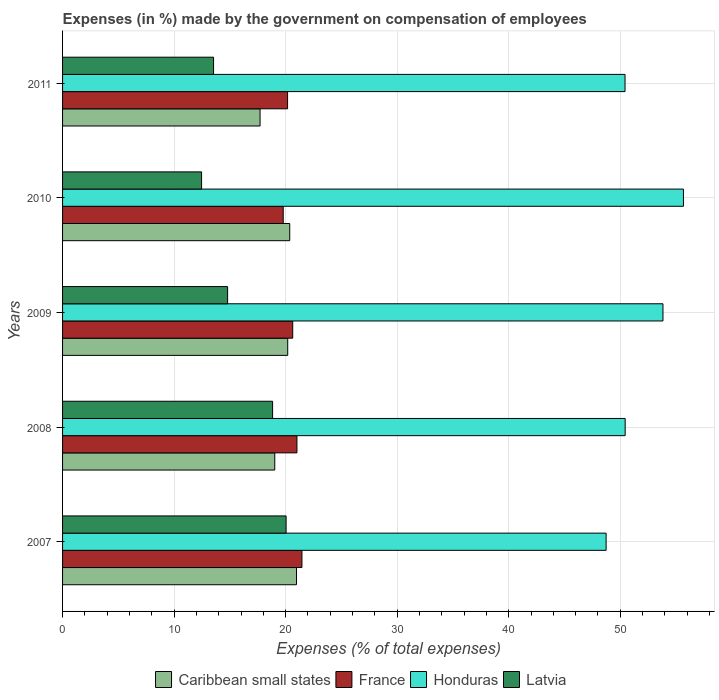Are the number of bars per tick equal to the number of legend labels?
Offer a very short reply. Yes. How many bars are there on the 4th tick from the top?
Provide a succinct answer. 4. What is the label of the 1st group of bars from the top?
Ensure brevity in your answer.  2011. What is the percentage of expenses made by the government on compensation of employees in Caribbean small states in 2010?
Your answer should be very brief. 20.37. Across all years, what is the maximum percentage of expenses made by the government on compensation of employees in France?
Your response must be concise. 21.46. Across all years, what is the minimum percentage of expenses made by the government on compensation of employees in Latvia?
Your answer should be compact. 12.46. What is the total percentage of expenses made by the government on compensation of employees in Latvia in the graph?
Your answer should be compact. 79.67. What is the difference between the percentage of expenses made by the government on compensation of employees in Honduras in 2007 and that in 2008?
Offer a very short reply. -1.71. What is the difference between the percentage of expenses made by the government on compensation of employees in France in 2010 and the percentage of expenses made by the government on compensation of employees in Honduras in 2011?
Provide a short and direct response. -30.65. What is the average percentage of expenses made by the government on compensation of employees in Caribbean small states per year?
Your answer should be very brief. 19.65. In the year 2010, what is the difference between the percentage of expenses made by the government on compensation of employees in Caribbean small states and percentage of expenses made by the government on compensation of employees in Latvia?
Your answer should be very brief. 7.91. What is the ratio of the percentage of expenses made by the government on compensation of employees in Latvia in 2007 to that in 2009?
Your answer should be very brief. 1.35. Is the difference between the percentage of expenses made by the government on compensation of employees in Caribbean small states in 2007 and 2011 greater than the difference between the percentage of expenses made by the government on compensation of employees in Latvia in 2007 and 2011?
Make the answer very short. No. What is the difference between the highest and the second highest percentage of expenses made by the government on compensation of employees in Caribbean small states?
Your answer should be compact. 0.61. What is the difference between the highest and the lowest percentage of expenses made by the government on compensation of employees in Latvia?
Give a very brief answer. 7.58. In how many years, is the percentage of expenses made by the government on compensation of employees in Caribbean small states greater than the average percentage of expenses made by the government on compensation of employees in Caribbean small states taken over all years?
Provide a succinct answer. 3. What does the 3rd bar from the top in 2011 represents?
Provide a succinct answer. France. What does the 3rd bar from the bottom in 2009 represents?
Your answer should be compact. Honduras. Is it the case that in every year, the sum of the percentage of expenses made by the government on compensation of employees in Latvia and percentage of expenses made by the government on compensation of employees in France is greater than the percentage of expenses made by the government on compensation of employees in Honduras?
Give a very brief answer. No. How many bars are there?
Offer a very short reply. 20. What is the difference between two consecutive major ticks on the X-axis?
Your response must be concise. 10. Does the graph contain any zero values?
Your answer should be compact. No. Does the graph contain grids?
Give a very brief answer. Yes. Where does the legend appear in the graph?
Make the answer very short. Bottom center. How many legend labels are there?
Your answer should be compact. 4. How are the legend labels stacked?
Your answer should be very brief. Horizontal. What is the title of the graph?
Keep it short and to the point. Expenses (in %) made by the government on compensation of employees. Does "Sweden" appear as one of the legend labels in the graph?
Keep it short and to the point. No. What is the label or title of the X-axis?
Your response must be concise. Expenses (% of total expenses). What is the label or title of the Y-axis?
Your answer should be compact. Years. What is the Expenses (% of total expenses) of Caribbean small states in 2007?
Your answer should be very brief. 20.98. What is the Expenses (% of total expenses) of France in 2007?
Keep it short and to the point. 21.46. What is the Expenses (% of total expenses) in Honduras in 2007?
Offer a very short reply. 48.73. What is the Expenses (% of total expenses) of Latvia in 2007?
Your answer should be compact. 20.04. What is the Expenses (% of total expenses) of Caribbean small states in 2008?
Your answer should be very brief. 19.03. What is the Expenses (% of total expenses) of France in 2008?
Provide a succinct answer. 21.01. What is the Expenses (% of total expenses) in Honduras in 2008?
Provide a short and direct response. 50.44. What is the Expenses (% of total expenses) of Latvia in 2008?
Ensure brevity in your answer.  18.83. What is the Expenses (% of total expenses) of Caribbean small states in 2009?
Provide a short and direct response. 20.19. What is the Expenses (% of total expenses) in France in 2009?
Your response must be concise. 20.63. What is the Expenses (% of total expenses) of Honduras in 2009?
Your answer should be very brief. 53.83. What is the Expenses (% of total expenses) of Latvia in 2009?
Keep it short and to the point. 14.8. What is the Expenses (% of total expenses) of Caribbean small states in 2010?
Your answer should be very brief. 20.37. What is the Expenses (% of total expenses) in France in 2010?
Give a very brief answer. 19.78. What is the Expenses (% of total expenses) of Honduras in 2010?
Offer a terse response. 55.67. What is the Expenses (% of total expenses) in Latvia in 2010?
Your response must be concise. 12.46. What is the Expenses (% of total expenses) in Caribbean small states in 2011?
Give a very brief answer. 17.71. What is the Expenses (% of total expenses) in France in 2011?
Offer a terse response. 20.17. What is the Expenses (% of total expenses) of Honduras in 2011?
Your answer should be compact. 50.43. What is the Expenses (% of total expenses) of Latvia in 2011?
Make the answer very short. 13.54. Across all years, what is the maximum Expenses (% of total expenses) of Caribbean small states?
Offer a very short reply. 20.98. Across all years, what is the maximum Expenses (% of total expenses) in France?
Ensure brevity in your answer.  21.46. Across all years, what is the maximum Expenses (% of total expenses) of Honduras?
Give a very brief answer. 55.67. Across all years, what is the maximum Expenses (% of total expenses) of Latvia?
Your answer should be compact. 20.04. Across all years, what is the minimum Expenses (% of total expenses) in Caribbean small states?
Provide a short and direct response. 17.71. Across all years, what is the minimum Expenses (% of total expenses) in France?
Make the answer very short. 19.78. Across all years, what is the minimum Expenses (% of total expenses) of Honduras?
Provide a succinct answer. 48.73. Across all years, what is the minimum Expenses (% of total expenses) in Latvia?
Give a very brief answer. 12.46. What is the total Expenses (% of total expenses) in Caribbean small states in the graph?
Your answer should be compact. 98.26. What is the total Expenses (% of total expenses) in France in the graph?
Ensure brevity in your answer.  103.07. What is the total Expenses (% of total expenses) of Honduras in the graph?
Make the answer very short. 259.1. What is the total Expenses (% of total expenses) of Latvia in the graph?
Make the answer very short. 79.67. What is the difference between the Expenses (% of total expenses) in Caribbean small states in 2007 and that in 2008?
Ensure brevity in your answer.  1.95. What is the difference between the Expenses (% of total expenses) of France in 2007 and that in 2008?
Provide a succinct answer. 0.45. What is the difference between the Expenses (% of total expenses) of Honduras in 2007 and that in 2008?
Your answer should be compact. -1.71. What is the difference between the Expenses (% of total expenses) in Latvia in 2007 and that in 2008?
Keep it short and to the point. 1.21. What is the difference between the Expenses (% of total expenses) of Caribbean small states in 2007 and that in 2009?
Provide a short and direct response. 0.79. What is the difference between the Expenses (% of total expenses) of France in 2007 and that in 2009?
Your answer should be very brief. 0.83. What is the difference between the Expenses (% of total expenses) in Honduras in 2007 and that in 2009?
Make the answer very short. -5.1. What is the difference between the Expenses (% of total expenses) in Latvia in 2007 and that in 2009?
Provide a short and direct response. 5.24. What is the difference between the Expenses (% of total expenses) of Caribbean small states in 2007 and that in 2010?
Give a very brief answer. 0.61. What is the difference between the Expenses (% of total expenses) in France in 2007 and that in 2010?
Your answer should be compact. 1.68. What is the difference between the Expenses (% of total expenses) in Honduras in 2007 and that in 2010?
Give a very brief answer. -6.93. What is the difference between the Expenses (% of total expenses) of Latvia in 2007 and that in 2010?
Provide a short and direct response. 7.58. What is the difference between the Expenses (% of total expenses) of Caribbean small states in 2007 and that in 2011?
Give a very brief answer. 3.27. What is the difference between the Expenses (% of total expenses) of France in 2007 and that in 2011?
Provide a short and direct response. 1.29. What is the difference between the Expenses (% of total expenses) in Honduras in 2007 and that in 2011?
Provide a short and direct response. -1.7. What is the difference between the Expenses (% of total expenses) in Latvia in 2007 and that in 2011?
Offer a terse response. 6.5. What is the difference between the Expenses (% of total expenses) in Caribbean small states in 2008 and that in 2009?
Ensure brevity in your answer.  -1.16. What is the difference between the Expenses (% of total expenses) in France in 2008 and that in 2009?
Give a very brief answer. 0.38. What is the difference between the Expenses (% of total expenses) of Honduras in 2008 and that in 2009?
Offer a very short reply. -3.39. What is the difference between the Expenses (% of total expenses) of Latvia in 2008 and that in 2009?
Make the answer very short. 4.03. What is the difference between the Expenses (% of total expenses) in Caribbean small states in 2008 and that in 2010?
Provide a short and direct response. -1.34. What is the difference between the Expenses (% of total expenses) in France in 2008 and that in 2010?
Offer a very short reply. 1.23. What is the difference between the Expenses (% of total expenses) in Honduras in 2008 and that in 2010?
Ensure brevity in your answer.  -5.23. What is the difference between the Expenses (% of total expenses) of Latvia in 2008 and that in 2010?
Offer a terse response. 6.37. What is the difference between the Expenses (% of total expenses) of Caribbean small states in 2008 and that in 2011?
Keep it short and to the point. 1.32. What is the difference between the Expenses (% of total expenses) in France in 2008 and that in 2011?
Your answer should be very brief. 0.84. What is the difference between the Expenses (% of total expenses) of Honduras in 2008 and that in 2011?
Offer a very short reply. 0.01. What is the difference between the Expenses (% of total expenses) in Latvia in 2008 and that in 2011?
Offer a terse response. 5.29. What is the difference between the Expenses (% of total expenses) of Caribbean small states in 2009 and that in 2010?
Provide a short and direct response. -0.18. What is the difference between the Expenses (% of total expenses) in France in 2009 and that in 2010?
Your response must be concise. 0.85. What is the difference between the Expenses (% of total expenses) of Honduras in 2009 and that in 2010?
Provide a short and direct response. -1.84. What is the difference between the Expenses (% of total expenses) in Latvia in 2009 and that in 2010?
Give a very brief answer. 2.33. What is the difference between the Expenses (% of total expenses) in Caribbean small states in 2009 and that in 2011?
Provide a succinct answer. 2.48. What is the difference between the Expenses (% of total expenses) of France in 2009 and that in 2011?
Ensure brevity in your answer.  0.46. What is the difference between the Expenses (% of total expenses) of Honduras in 2009 and that in 2011?
Offer a terse response. 3.4. What is the difference between the Expenses (% of total expenses) of Latvia in 2009 and that in 2011?
Make the answer very short. 1.26. What is the difference between the Expenses (% of total expenses) in Caribbean small states in 2010 and that in 2011?
Your answer should be very brief. 2.66. What is the difference between the Expenses (% of total expenses) of France in 2010 and that in 2011?
Your response must be concise. -0.39. What is the difference between the Expenses (% of total expenses) of Honduras in 2010 and that in 2011?
Give a very brief answer. 5.24. What is the difference between the Expenses (% of total expenses) of Latvia in 2010 and that in 2011?
Make the answer very short. -1.07. What is the difference between the Expenses (% of total expenses) in Caribbean small states in 2007 and the Expenses (% of total expenses) in France in 2008?
Provide a short and direct response. -0.04. What is the difference between the Expenses (% of total expenses) in Caribbean small states in 2007 and the Expenses (% of total expenses) in Honduras in 2008?
Provide a succinct answer. -29.47. What is the difference between the Expenses (% of total expenses) in Caribbean small states in 2007 and the Expenses (% of total expenses) in Latvia in 2008?
Ensure brevity in your answer.  2.15. What is the difference between the Expenses (% of total expenses) of France in 2007 and the Expenses (% of total expenses) of Honduras in 2008?
Give a very brief answer. -28.98. What is the difference between the Expenses (% of total expenses) of France in 2007 and the Expenses (% of total expenses) of Latvia in 2008?
Offer a terse response. 2.63. What is the difference between the Expenses (% of total expenses) in Honduras in 2007 and the Expenses (% of total expenses) in Latvia in 2008?
Give a very brief answer. 29.9. What is the difference between the Expenses (% of total expenses) in Caribbean small states in 2007 and the Expenses (% of total expenses) in France in 2009?
Ensure brevity in your answer.  0.34. What is the difference between the Expenses (% of total expenses) in Caribbean small states in 2007 and the Expenses (% of total expenses) in Honduras in 2009?
Your answer should be compact. -32.86. What is the difference between the Expenses (% of total expenses) in Caribbean small states in 2007 and the Expenses (% of total expenses) in Latvia in 2009?
Your answer should be compact. 6.18. What is the difference between the Expenses (% of total expenses) in France in 2007 and the Expenses (% of total expenses) in Honduras in 2009?
Your answer should be very brief. -32.37. What is the difference between the Expenses (% of total expenses) of France in 2007 and the Expenses (% of total expenses) of Latvia in 2009?
Provide a short and direct response. 6.66. What is the difference between the Expenses (% of total expenses) in Honduras in 2007 and the Expenses (% of total expenses) in Latvia in 2009?
Offer a terse response. 33.94. What is the difference between the Expenses (% of total expenses) of Caribbean small states in 2007 and the Expenses (% of total expenses) of France in 2010?
Keep it short and to the point. 1.19. What is the difference between the Expenses (% of total expenses) of Caribbean small states in 2007 and the Expenses (% of total expenses) of Honduras in 2010?
Ensure brevity in your answer.  -34.69. What is the difference between the Expenses (% of total expenses) of Caribbean small states in 2007 and the Expenses (% of total expenses) of Latvia in 2010?
Offer a very short reply. 8.51. What is the difference between the Expenses (% of total expenses) of France in 2007 and the Expenses (% of total expenses) of Honduras in 2010?
Make the answer very short. -34.21. What is the difference between the Expenses (% of total expenses) of France in 2007 and the Expenses (% of total expenses) of Latvia in 2010?
Provide a short and direct response. 9. What is the difference between the Expenses (% of total expenses) of Honduras in 2007 and the Expenses (% of total expenses) of Latvia in 2010?
Offer a very short reply. 36.27. What is the difference between the Expenses (% of total expenses) in Caribbean small states in 2007 and the Expenses (% of total expenses) in France in 2011?
Your answer should be compact. 0.8. What is the difference between the Expenses (% of total expenses) in Caribbean small states in 2007 and the Expenses (% of total expenses) in Honduras in 2011?
Make the answer very short. -29.45. What is the difference between the Expenses (% of total expenses) of Caribbean small states in 2007 and the Expenses (% of total expenses) of Latvia in 2011?
Ensure brevity in your answer.  7.44. What is the difference between the Expenses (% of total expenses) in France in 2007 and the Expenses (% of total expenses) in Honduras in 2011?
Ensure brevity in your answer.  -28.97. What is the difference between the Expenses (% of total expenses) in France in 2007 and the Expenses (% of total expenses) in Latvia in 2011?
Keep it short and to the point. 7.92. What is the difference between the Expenses (% of total expenses) of Honduras in 2007 and the Expenses (% of total expenses) of Latvia in 2011?
Provide a succinct answer. 35.19. What is the difference between the Expenses (% of total expenses) in Caribbean small states in 2008 and the Expenses (% of total expenses) in France in 2009?
Provide a short and direct response. -1.61. What is the difference between the Expenses (% of total expenses) in Caribbean small states in 2008 and the Expenses (% of total expenses) in Honduras in 2009?
Offer a very short reply. -34.81. What is the difference between the Expenses (% of total expenses) of Caribbean small states in 2008 and the Expenses (% of total expenses) of Latvia in 2009?
Provide a succinct answer. 4.23. What is the difference between the Expenses (% of total expenses) of France in 2008 and the Expenses (% of total expenses) of Honduras in 2009?
Give a very brief answer. -32.82. What is the difference between the Expenses (% of total expenses) in France in 2008 and the Expenses (% of total expenses) in Latvia in 2009?
Your response must be concise. 6.22. What is the difference between the Expenses (% of total expenses) of Honduras in 2008 and the Expenses (% of total expenses) of Latvia in 2009?
Offer a very short reply. 35.64. What is the difference between the Expenses (% of total expenses) of Caribbean small states in 2008 and the Expenses (% of total expenses) of France in 2010?
Give a very brief answer. -0.76. What is the difference between the Expenses (% of total expenses) in Caribbean small states in 2008 and the Expenses (% of total expenses) in Honduras in 2010?
Give a very brief answer. -36.64. What is the difference between the Expenses (% of total expenses) in Caribbean small states in 2008 and the Expenses (% of total expenses) in Latvia in 2010?
Your answer should be very brief. 6.56. What is the difference between the Expenses (% of total expenses) of France in 2008 and the Expenses (% of total expenses) of Honduras in 2010?
Make the answer very short. -34.65. What is the difference between the Expenses (% of total expenses) of France in 2008 and the Expenses (% of total expenses) of Latvia in 2010?
Provide a short and direct response. 8.55. What is the difference between the Expenses (% of total expenses) of Honduras in 2008 and the Expenses (% of total expenses) of Latvia in 2010?
Give a very brief answer. 37.98. What is the difference between the Expenses (% of total expenses) of Caribbean small states in 2008 and the Expenses (% of total expenses) of France in 2011?
Make the answer very short. -1.15. What is the difference between the Expenses (% of total expenses) in Caribbean small states in 2008 and the Expenses (% of total expenses) in Honduras in 2011?
Your answer should be compact. -31.4. What is the difference between the Expenses (% of total expenses) in Caribbean small states in 2008 and the Expenses (% of total expenses) in Latvia in 2011?
Give a very brief answer. 5.49. What is the difference between the Expenses (% of total expenses) of France in 2008 and the Expenses (% of total expenses) of Honduras in 2011?
Offer a terse response. -29.41. What is the difference between the Expenses (% of total expenses) of France in 2008 and the Expenses (% of total expenses) of Latvia in 2011?
Provide a short and direct response. 7.48. What is the difference between the Expenses (% of total expenses) in Honduras in 2008 and the Expenses (% of total expenses) in Latvia in 2011?
Ensure brevity in your answer.  36.9. What is the difference between the Expenses (% of total expenses) of Caribbean small states in 2009 and the Expenses (% of total expenses) of France in 2010?
Your answer should be compact. 0.4. What is the difference between the Expenses (% of total expenses) in Caribbean small states in 2009 and the Expenses (% of total expenses) in Honduras in 2010?
Offer a terse response. -35.48. What is the difference between the Expenses (% of total expenses) of Caribbean small states in 2009 and the Expenses (% of total expenses) of Latvia in 2010?
Offer a very short reply. 7.72. What is the difference between the Expenses (% of total expenses) in France in 2009 and the Expenses (% of total expenses) in Honduras in 2010?
Keep it short and to the point. -35.03. What is the difference between the Expenses (% of total expenses) of France in 2009 and the Expenses (% of total expenses) of Latvia in 2010?
Make the answer very short. 8.17. What is the difference between the Expenses (% of total expenses) of Honduras in 2009 and the Expenses (% of total expenses) of Latvia in 2010?
Your response must be concise. 41.37. What is the difference between the Expenses (% of total expenses) in Caribbean small states in 2009 and the Expenses (% of total expenses) in France in 2011?
Provide a succinct answer. 0.01. What is the difference between the Expenses (% of total expenses) of Caribbean small states in 2009 and the Expenses (% of total expenses) of Honduras in 2011?
Make the answer very short. -30.24. What is the difference between the Expenses (% of total expenses) in Caribbean small states in 2009 and the Expenses (% of total expenses) in Latvia in 2011?
Make the answer very short. 6.65. What is the difference between the Expenses (% of total expenses) in France in 2009 and the Expenses (% of total expenses) in Honduras in 2011?
Provide a short and direct response. -29.79. What is the difference between the Expenses (% of total expenses) of France in 2009 and the Expenses (% of total expenses) of Latvia in 2011?
Your response must be concise. 7.1. What is the difference between the Expenses (% of total expenses) in Honduras in 2009 and the Expenses (% of total expenses) in Latvia in 2011?
Your response must be concise. 40.29. What is the difference between the Expenses (% of total expenses) in Caribbean small states in 2010 and the Expenses (% of total expenses) in France in 2011?
Provide a succinct answer. 0.19. What is the difference between the Expenses (% of total expenses) in Caribbean small states in 2010 and the Expenses (% of total expenses) in Honduras in 2011?
Provide a short and direct response. -30.06. What is the difference between the Expenses (% of total expenses) in Caribbean small states in 2010 and the Expenses (% of total expenses) in Latvia in 2011?
Ensure brevity in your answer.  6.83. What is the difference between the Expenses (% of total expenses) of France in 2010 and the Expenses (% of total expenses) of Honduras in 2011?
Offer a very short reply. -30.65. What is the difference between the Expenses (% of total expenses) of France in 2010 and the Expenses (% of total expenses) of Latvia in 2011?
Your answer should be compact. 6.25. What is the difference between the Expenses (% of total expenses) in Honduras in 2010 and the Expenses (% of total expenses) in Latvia in 2011?
Offer a very short reply. 42.13. What is the average Expenses (% of total expenses) in Caribbean small states per year?
Keep it short and to the point. 19.65. What is the average Expenses (% of total expenses) of France per year?
Provide a short and direct response. 20.61. What is the average Expenses (% of total expenses) of Honduras per year?
Give a very brief answer. 51.82. What is the average Expenses (% of total expenses) in Latvia per year?
Your answer should be very brief. 15.93. In the year 2007, what is the difference between the Expenses (% of total expenses) in Caribbean small states and Expenses (% of total expenses) in France?
Keep it short and to the point. -0.49. In the year 2007, what is the difference between the Expenses (% of total expenses) of Caribbean small states and Expenses (% of total expenses) of Honduras?
Your answer should be compact. -27.76. In the year 2007, what is the difference between the Expenses (% of total expenses) of Caribbean small states and Expenses (% of total expenses) of Latvia?
Ensure brevity in your answer.  0.93. In the year 2007, what is the difference between the Expenses (% of total expenses) of France and Expenses (% of total expenses) of Honduras?
Your answer should be compact. -27.27. In the year 2007, what is the difference between the Expenses (% of total expenses) in France and Expenses (% of total expenses) in Latvia?
Make the answer very short. 1.42. In the year 2007, what is the difference between the Expenses (% of total expenses) of Honduras and Expenses (% of total expenses) of Latvia?
Ensure brevity in your answer.  28.69. In the year 2008, what is the difference between the Expenses (% of total expenses) in Caribbean small states and Expenses (% of total expenses) in France?
Your answer should be compact. -1.99. In the year 2008, what is the difference between the Expenses (% of total expenses) in Caribbean small states and Expenses (% of total expenses) in Honduras?
Provide a short and direct response. -31.42. In the year 2008, what is the difference between the Expenses (% of total expenses) of Caribbean small states and Expenses (% of total expenses) of Latvia?
Offer a terse response. 0.2. In the year 2008, what is the difference between the Expenses (% of total expenses) of France and Expenses (% of total expenses) of Honduras?
Your answer should be very brief. -29.43. In the year 2008, what is the difference between the Expenses (% of total expenses) in France and Expenses (% of total expenses) in Latvia?
Your response must be concise. 2.18. In the year 2008, what is the difference between the Expenses (% of total expenses) of Honduras and Expenses (% of total expenses) of Latvia?
Ensure brevity in your answer.  31.61. In the year 2009, what is the difference between the Expenses (% of total expenses) in Caribbean small states and Expenses (% of total expenses) in France?
Offer a terse response. -0.45. In the year 2009, what is the difference between the Expenses (% of total expenses) of Caribbean small states and Expenses (% of total expenses) of Honduras?
Offer a terse response. -33.64. In the year 2009, what is the difference between the Expenses (% of total expenses) of Caribbean small states and Expenses (% of total expenses) of Latvia?
Provide a short and direct response. 5.39. In the year 2009, what is the difference between the Expenses (% of total expenses) of France and Expenses (% of total expenses) of Honduras?
Provide a short and direct response. -33.2. In the year 2009, what is the difference between the Expenses (% of total expenses) of France and Expenses (% of total expenses) of Latvia?
Provide a succinct answer. 5.84. In the year 2009, what is the difference between the Expenses (% of total expenses) of Honduras and Expenses (% of total expenses) of Latvia?
Provide a succinct answer. 39.03. In the year 2010, what is the difference between the Expenses (% of total expenses) of Caribbean small states and Expenses (% of total expenses) of France?
Provide a succinct answer. 0.58. In the year 2010, what is the difference between the Expenses (% of total expenses) in Caribbean small states and Expenses (% of total expenses) in Honduras?
Provide a short and direct response. -35.3. In the year 2010, what is the difference between the Expenses (% of total expenses) in Caribbean small states and Expenses (% of total expenses) in Latvia?
Your answer should be very brief. 7.91. In the year 2010, what is the difference between the Expenses (% of total expenses) in France and Expenses (% of total expenses) in Honduras?
Provide a succinct answer. -35.88. In the year 2010, what is the difference between the Expenses (% of total expenses) of France and Expenses (% of total expenses) of Latvia?
Your answer should be compact. 7.32. In the year 2010, what is the difference between the Expenses (% of total expenses) in Honduras and Expenses (% of total expenses) in Latvia?
Make the answer very short. 43.2. In the year 2011, what is the difference between the Expenses (% of total expenses) in Caribbean small states and Expenses (% of total expenses) in France?
Provide a short and direct response. -2.47. In the year 2011, what is the difference between the Expenses (% of total expenses) in Caribbean small states and Expenses (% of total expenses) in Honduras?
Provide a short and direct response. -32.72. In the year 2011, what is the difference between the Expenses (% of total expenses) in Caribbean small states and Expenses (% of total expenses) in Latvia?
Ensure brevity in your answer.  4.17. In the year 2011, what is the difference between the Expenses (% of total expenses) of France and Expenses (% of total expenses) of Honduras?
Your response must be concise. -30.25. In the year 2011, what is the difference between the Expenses (% of total expenses) in France and Expenses (% of total expenses) in Latvia?
Your answer should be very brief. 6.64. In the year 2011, what is the difference between the Expenses (% of total expenses) of Honduras and Expenses (% of total expenses) of Latvia?
Make the answer very short. 36.89. What is the ratio of the Expenses (% of total expenses) in Caribbean small states in 2007 to that in 2008?
Ensure brevity in your answer.  1.1. What is the ratio of the Expenses (% of total expenses) of France in 2007 to that in 2008?
Your answer should be very brief. 1.02. What is the ratio of the Expenses (% of total expenses) of Honduras in 2007 to that in 2008?
Provide a short and direct response. 0.97. What is the ratio of the Expenses (% of total expenses) in Latvia in 2007 to that in 2008?
Give a very brief answer. 1.06. What is the ratio of the Expenses (% of total expenses) of Caribbean small states in 2007 to that in 2009?
Give a very brief answer. 1.04. What is the ratio of the Expenses (% of total expenses) in France in 2007 to that in 2009?
Provide a succinct answer. 1.04. What is the ratio of the Expenses (% of total expenses) in Honduras in 2007 to that in 2009?
Give a very brief answer. 0.91. What is the ratio of the Expenses (% of total expenses) of Latvia in 2007 to that in 2009?
Keep it short and to the point. 1.35. What is the ratio of the Expenses (% of total expenses) in Caribbean small states in 2007 to that in 2010?
Offer a very short reply. 1.03. What is the ratio of the Expenses (% of total expenses) of France in 2007 to that in 2010?
Make the answer very short. 1.08. What is the ratio of the Expenses (% of total expenses) in Honduras in 2007 to that in 2010?
Ensure brevity in your answer.  0.88. What is the ratio of the Expenses (% of total expenses) in Latvia in 2007 to that in 2010?
Offer a terse response. 1.61. What is the ratio of the Expenses (% of total expenses) of Caribbean small states in 2007 to that in 2011?
Your answer should be compact. 1.18. What is the ratio of the Expenses (% of total expenses) in France in 2007 to that in 2011?
Provide a succinct answer. 1.06. What is the ratio of the Expenses (% of total expenses) of Honduras in 2007 to that in 2011?
Your response must be concise. 0.97. What is the ratio of the Expenses (% of total expenses) in Latvia in 2007 to that in 2011?
Provide a succinct answer. 1.48. What is the ratio of the Expenses (% of total expenses) in Caribbean small states in 2008 to that in 2009?
Give a very brief answer. 0.94. What is the ratio of the Expenses (% of total expenses) of France in 2008 to that in 2009?
Keep it short and to the point. 1.02. What is the ratio of the Expenses (% of total expenses) of Honduras in 2008 to that in 2009?
Give a very brief answer. 0.94. What is the ratio of the Expenses (% of total expenses) in Latvia in 2008 to that in 2009?
Your answer should be very brief. 1.27. What is the ratio of the Expenses (% of total expenses) of Caribbean small states in 2008 to that in 2010?
Keep it short and to the point. 0.93. What is the ratio of the Expenses (% of total expenses) of France in 2008 to that in 2010?
Offer a very short reply. 1.06. What is the ratio of the Expenses (% of total expenses) of Honduras in 2008 to that in 2010?
Offer a terse response. 0.91. What is the ratio of the Expenses (% of total expenses) in Latvia in 2008 to that in 2010?
Offer a terse response. 1.51. What is the ratio of the Expenses (% of total expenses) in Caribbean small states in 2008 to that in 2011?
Provide a short and direct response. 1.07. What is the ratio of the Expenses (% of total expenses) in France in 2008 to that in 2011?
Your answer should be compact. 1.04. What is the ratio of the Expenses (% of total expenses) in Honduras in 2008 to that in 2011?
Your response must be concise. 1. What is the ratio of the Expenses (% of total expenses) in Latvia in 2008 to that in 2011?
Your answer should be compact. 1.39. What is the ratio of the Expenses (% of total expenses) of Caribbean small states in 2009 to that in 2010?
Your answer should be very brief. 0.99. What is the ratio of the Expenses (% of total expenses) of France in 2009 to that in 2010?
Your response must be concise. 1.04. What is the ratio of the Expenses (% of total expenses) of Honduras in 2009 to that in 2010?
Offer a very short reply. 0.97. What is the ratio of the Expenses (% of total expenses) in Latvia in 2009 to that in 2010?
Offer a terse response. 1.19. What is the ratio of the Expenses (% of total expenses) of Caribbean small states in 2009 to that in 2011?
Your response must be concise. 1.14. What is the ratio of the Expenses (% of total expenses) in France in 2009 to that in 2011?
Provide a succinct answer. 1.02. What is the ratio of the Expenses (% of total expenses) of Honduras in 2009 to that in 2011?
Your answer should be compact. 1.07. What is the ratio of the Expenses (% of total expenses) of Latvia in 2009 to that in 2011?
Provide a succinct answer. 1.09. What is the ratio of the Expenses (% of total expenses) of Caribbean small states in 2010 to that in 2011?
Give a very brief answer. 1.15. What is the ratio of the Expenses (% of total expenses) of France in 2010 to that in 2011?
Give a very brief answer. 0.98. What is the ratio of the Expenses (% of total expenses) of Honduras in 2010 to that in 2011?
Provide a succinct answer. 1.1. What is the ratio of the Expenses (% of total expenses) in Latvia in 2010 to that in 2011?
Offer a very short reply. 0.92. What is the difference between the highest and the second highest Expenses (% of total expenses) in Caribbean small states?
Make the answer very short. 0.61. What is the difference between the highest and the second highest Expenses (% of total expenses) of France?
Keep it short and to the point. 0.45. What is the difference between the highest and the second highest Expenses (% of total expenses) of Honduras?
Provide a short and direct response. 1.84. What is the difference between the highest and the second highest Expenses (% of total expenses) of Latvia?
Offer a very short reply. 1.21. What is the difference between the highest and the lowest Expenses (% of total expenses) in Caribbean small states?
Your response must be concise. 3.27. What is the difference between the highest and the lowest Expenses (% of total expenses) of France?
Ensure brevity in your answer.  1.68. What is the difference between the highest and the lowest Expenses (% of total expenses) of Honduras?
Make the answer very short. 6.93. What is the difference between the highest and the lowest Expenses (% of total expenses) in Latvia?
Give a very brief answer. 7.58. 